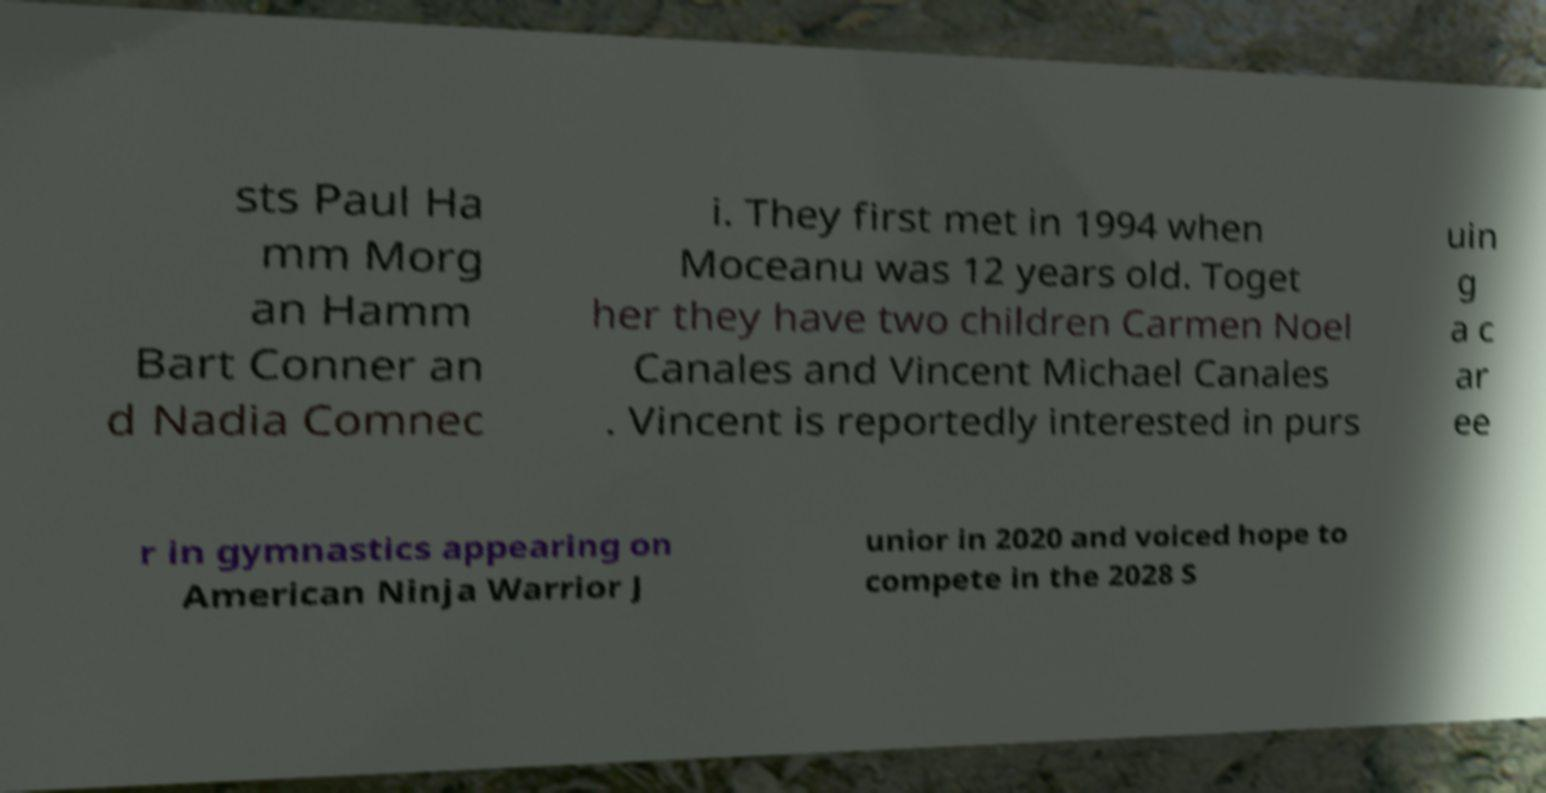Could you assist in decoding the text presented in this image and type it out clearly? sts Paul Ha mm Morg an Hamm Bart Conner an d Nadia Comnec i. They first met in 1994 when Moceanu was 12 years old. Toget her they have two children Carmen Noel Canales and Vincent Michael Canales . Vincent is reportedly interested in purs uin g a c ar ee r in gymnastics appearing on American Ninja Warrior J unior in 2020 and voiced hope to compete in the 2028 S 